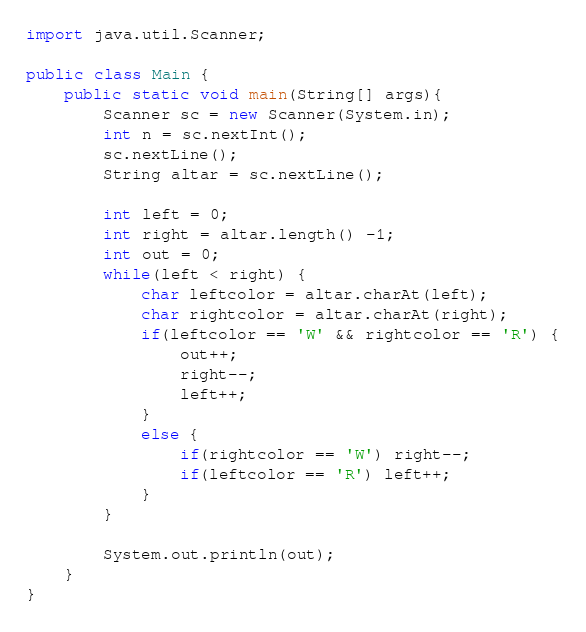Convert code to text. <code><loc_0><loc_0><loc_500><loc_500><_Java_>import java.util.Scanner;

public class Main {
	public static void main(String[] args){
		Scanner sc = new Scanner(System.in);
		int n = sc.nextInt();
		sc.nextLine();
		String altar = sc.nextLine();
		
		int left = 0;
		int right = altar.length() -1;
		int out = 0;
		while(left < right) {
			char leftcolor = altar.charAt(left);
			char rightcolor = altar.charAt(right);
			if(leftcolor == 'W' && rightcolor == 'R') {
				out++;
				right--;
				left++;
			}
			else {
				if(rightcolor == 'W') right--;
				if(leftcolor == 'R') left++;
			}
		}
		
		System.out.println(out);
	}
}
</code> 